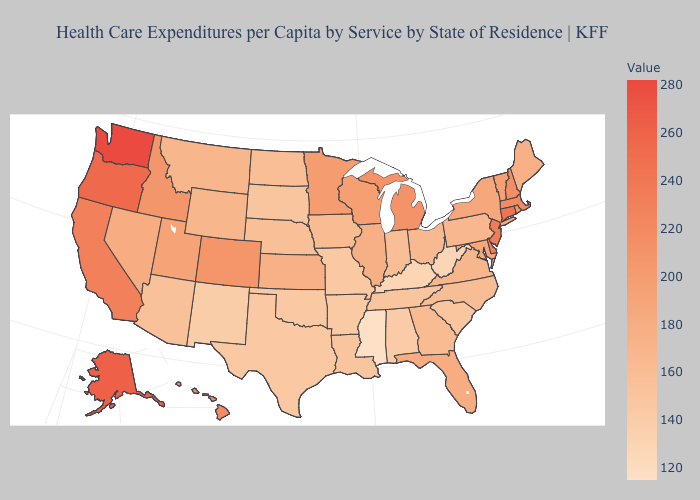Does Mississippi have the lowest value in the USA?
Keep it brief. Yes. Among the states that border Georgia , does Florida have the lowest value?
Keep it brief. No. Does West Virginia have a higher value than Georgia?
Short answer required. No. Does the map have missing data?
Short answer required. No. Which states have the lowest value in the West?
Be succinct. New Mexico. Which states have the lowest value in the USA?
Concise answer only. Mississippi. Does Washington have the highest value in the USA?
Answer briefly. Yes. 